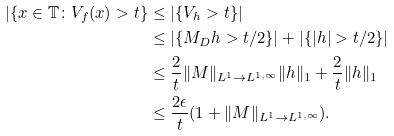<formula> <loc_0><loc_0><loc_500><loc_500>| \{ x \in \mathbb { T } \colon V _ { f } ( x ) > t \} & \leq | \{ V _ { h } > t \} | \\ & \leq | \{ M _ { D } h > t / 2 \} | + | \{ | h | > t / 2 \} | \\ & \leq \frac { 2 } { t } \| M \| _ { L ^ { 1 } \rightarrow L ^ { 1 , \infty } } \| h \| _ { 1 } + \frac { 2 } { t } \| h \| _ { 1 } \\ & \leq \frac { 2 \epsilon } { t } ( 1 + \| M \| _ { L ^ { 1 } \rightarrow L ^ { 1 , \infty } } ) .</formula> 